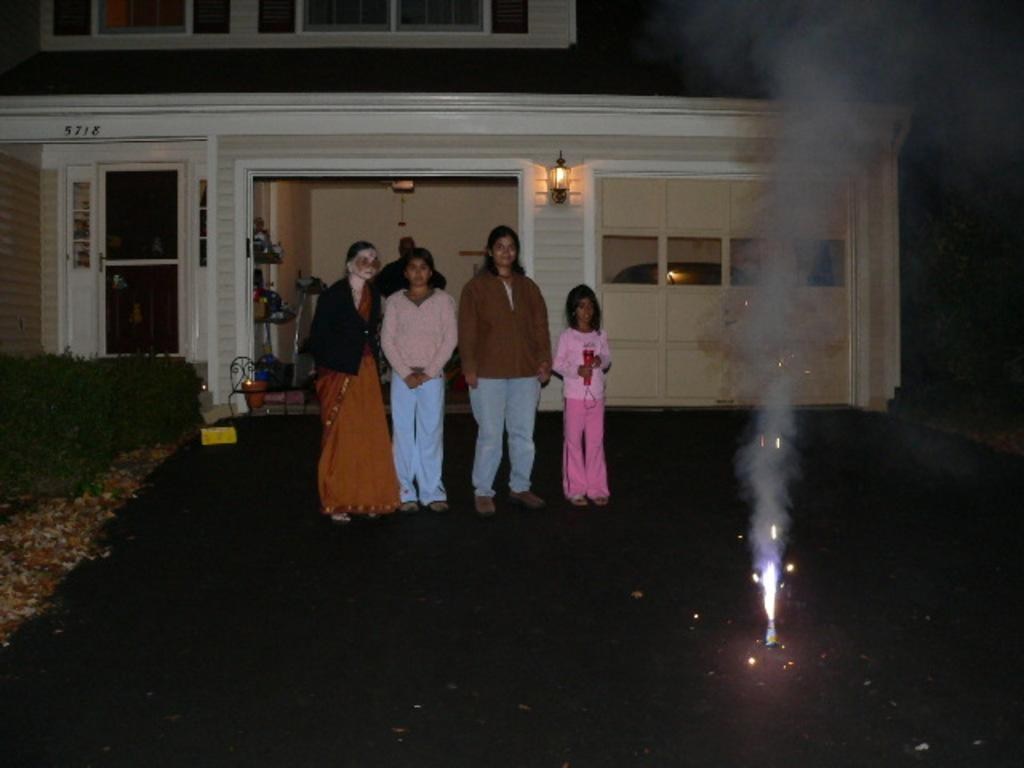What is happening in the image? There are people standing in the image. What object is in front of the people? There is a cracker in front of the people. What can be seen on the left side of the image? There are plants on the left side of the image. What is located behind the plants? There is a building behind the plants. What type of art is displayed on the tray in the image? There is no tray present in the image, so it is not possible to determine if any art is displayed on it. 